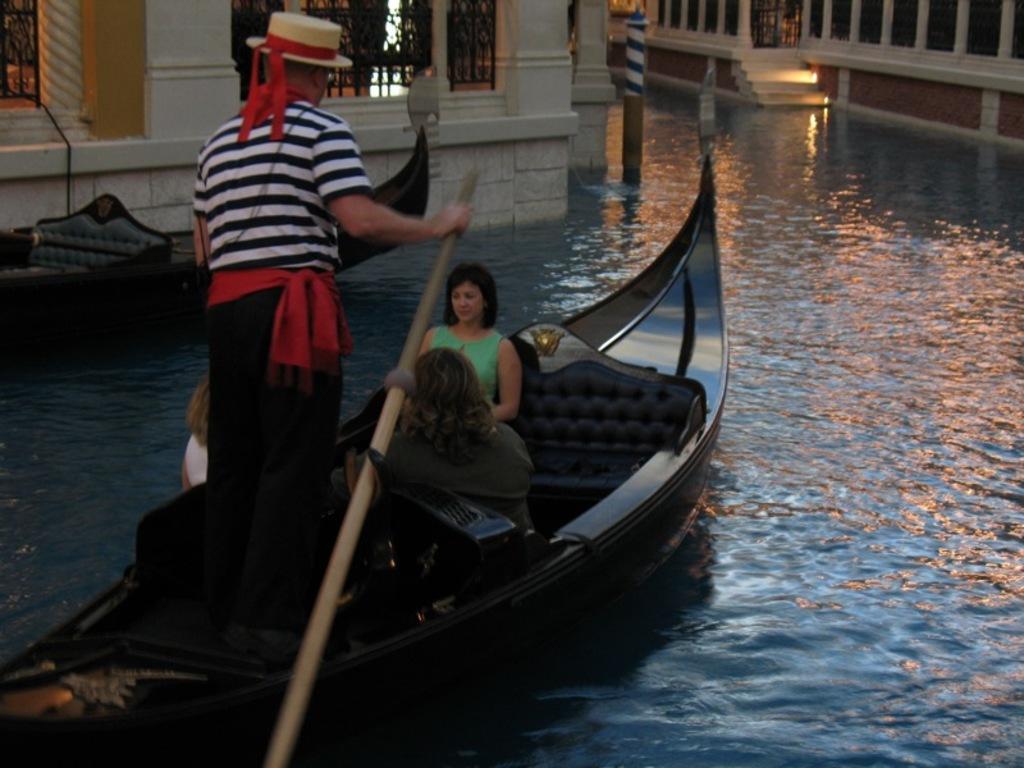Please provide a concise description of this image. In this image there is water and we can see boats on the water. There are people in the boats. In the background there are buildings. 